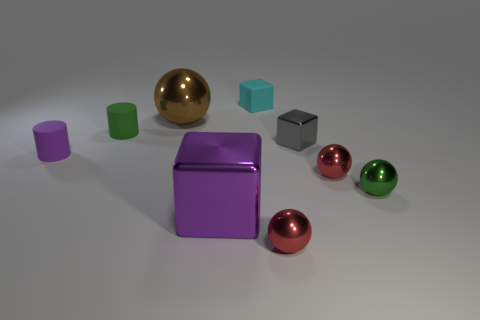Is there anything else of the same color as the large shiny ball?
Provide a succinct answer. No. What number of metallic things are big spheres or cyan cubes?
Provide a succinct answer. 1. What is the material of the green sphere that is the same size as the gray object?
Offer a very short reply. Metal. Are there any objects that have the same material as the small gray cube?
Your answer should be compact. Yes. There is a green thing that is left of the matte object behind the large metallic object behind the tiny metal block; what is its shape?
Ensure brevity in your answer.  Cylinder. Do the purple metallic thing and the brown thing that is behind the tiny green ball have the same size?
Provide a succinct answer. Yes. There is a object that is on the right side of the large ball and behind the small green matte thing; what shape is it?
Your response must be concise. Cube. How many small things are cyan shiny things or purple rubber things?
Make the answer very short. 1. Are there the same number of cyan matte blocks that are right of the cyan block and shiny things on the right side of the big purple shiny block?
Your answer should be compact. No. What number of other objects are there of the same color as the big metallic cube?
Make the answer very short. 1. 